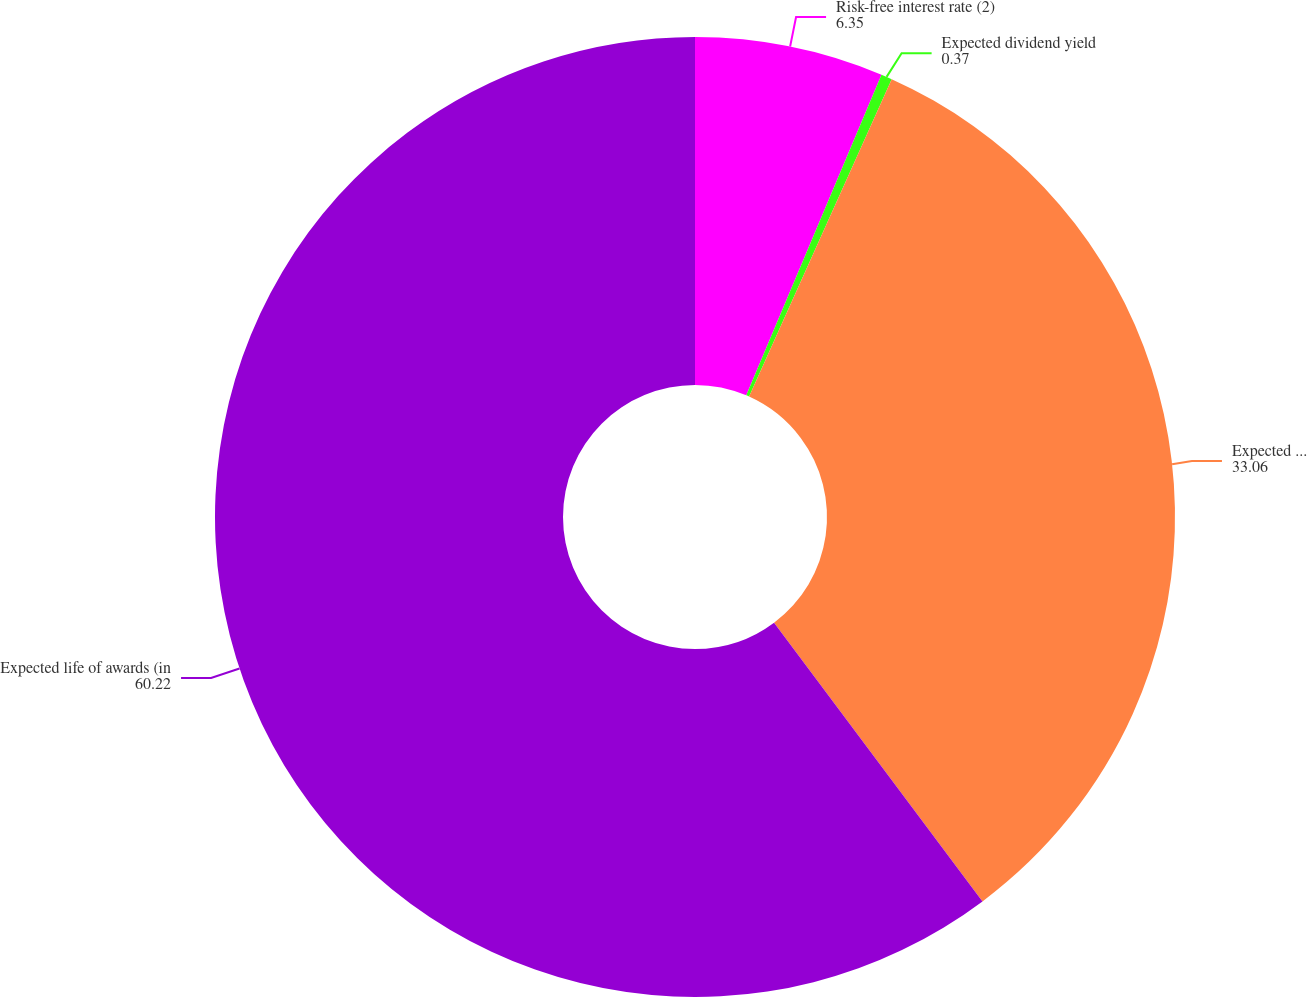<chart> <loc_0><loc_0><loc_500><loc_500><pie_chart><fcel>Risk-free interest rate (2)<fcel>Expected dividend yield<fcel>Expected stock price<fcel>Expected life of awards (in<nl><fcel>6.35%<fcel>0.37%<fcel>33.06%<fcel>60.22%<nl></chart> 